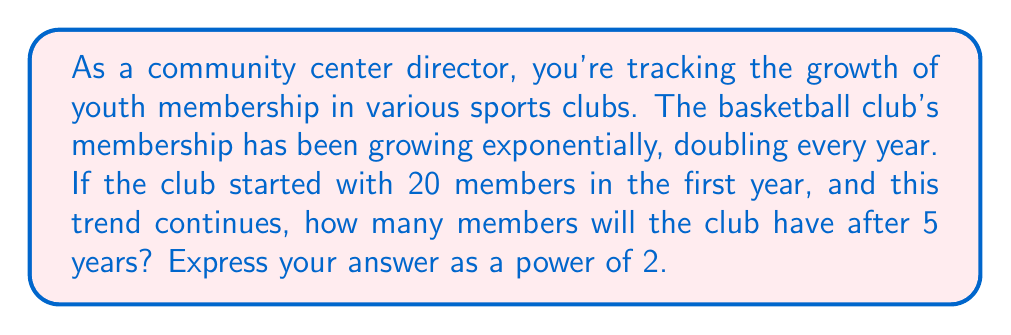Show me your answer to this math problem. Let's approach this step-by-step:

1) The initial number of members is 20.

2) The membership doubles every year. This means we're dealing with an exponential growth with a base of 2.

3) We can express this growth using the formula:

   $$a_n = a_1 \cdot r^{n-1}$$

   Where:
   $a_n$ is the number of members after n years
   $a_1$ is the initial number of members
   $r$ is the growth rate (in this case, 2)
   $n$ is the number of years

4) Substituting our values:

   $$a_5 = 20 \cdot 2^{5-1}$$

5) Simplify:

   $$a_5 = 20 \cdot 2^4$$

6) Expand:

   $$a_5 = 20 \cdot 16 = 320$$

7) Now, we need to express this as a power of 2:

   $$320 = 20 \cdot 16 = (2^2 \cdot 5) \cdot 2^4 = 2^6 \cdot 5$$

Therefore, after 5 years, the club will have $2^6 \cdot 5$ members.
Answer: $2^6 \cdot 5$ members 